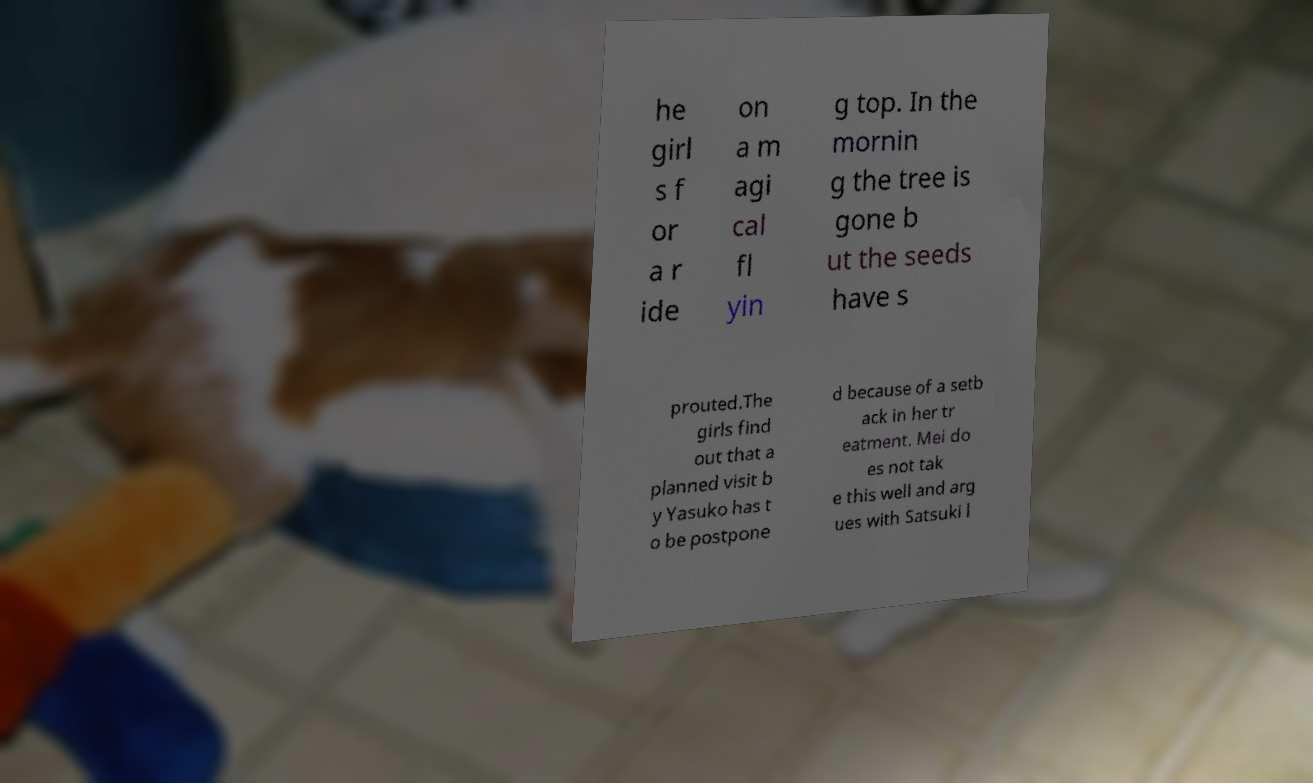For documentation purposes, I need the text within this image transcribed. Could you provide that? he girl s f or a r ide on a m agi cal fl yin g top. In the mornin g the tree is gone b ut the seeds have s prouted.The girls find out that a planned visit b y Yasuko has t o be postpone d because of a setb ack in her tr eatment. Mei do es not tak e this well and arg ues with Satsuki l 